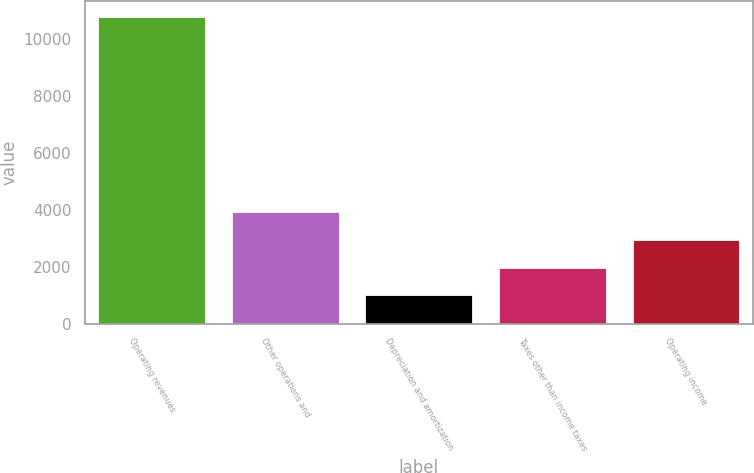<chart> <loc_0><loc_0><loc_500><loc_500><bar_chart><fcel>Operating revenues<fcel>Other operations and<fcel>Depreciation and amortization<fcel>Taxes other than income taxes<fcel>Operating income<nl><fcel>10786<fcel>3929.5<fcel>991<fcel>1970.5<fcel>2950<nl></chart> 